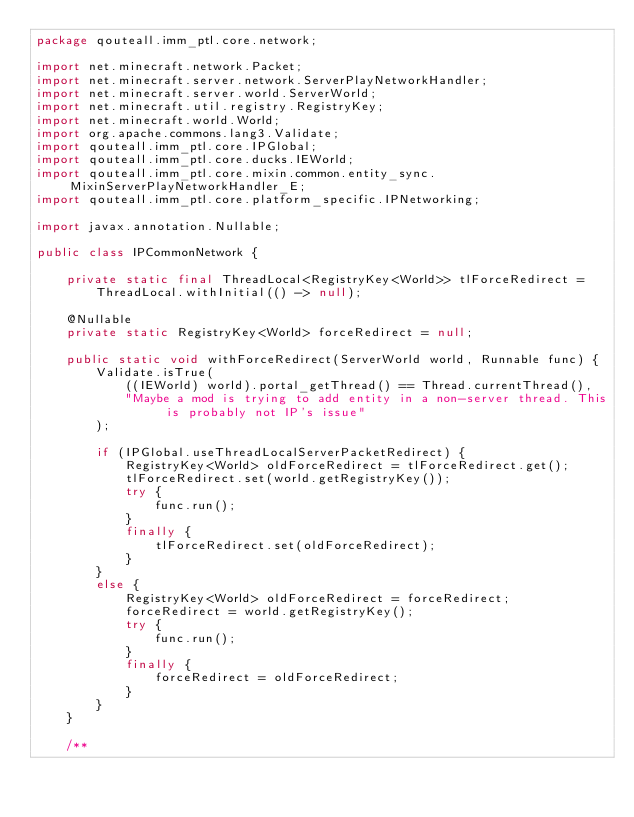<code> <loc_0><loc_0><loc_500><loc_500><_Java_>package qouteall.imm_ptl.core.network;

import net.minecraft.network.Packet;
import net.minecraft.server.network.ServerPlayNetworkHandler;
import net.minecraft.server.world.ServerWorld;
import net.minecraft.util.registry.RegistryKey;
import net.minecraft.world.World;
import org.apache.commons.lang3.Validate;
import qouteall.imm_ptl.core.IPGlobal;
import qouteall.imm_ptl.core.ducks.IEWorld;
import qouteall.imm_ptl.core.mixin.common.entity_sync.MixinServerPlayNetworkHandler_E;
import qouteall.imm_ptl.core.platform_specific.IPNetworking;

import javax.annotation.Nullable;

public class IPCommonNetwork {
    
    private static final ThreadLocal<RegistryKey<World>> tlForceRedirect =
        ThreadLocal.withInitial(() -> null);
    
    @Nullable
    private static RegistryKey<World> forceRedirect = null;
    
    public static void withForceRedirect(ServerWorld world, Runnable func) {
        Validate.isTrue(
            ((IEWorld) world).portal_getThread() == Thread.currentThread(),
            "Maybe a mod is trying to add entity in a non-server thread. This is probably not IP's issue"
        );
        
        if (IPGlobal.useThreadLocalServerPacketRedirect) {
            RegistryKey<World> oldForceRedirect = tlForceRedirect.get();
            tlForceRedirect.set(world.getRegistryKey());
            try {
                func.run();
            }
            finally {
                tlForceRedirect.set(oldForceRedirect);
            }
        }
        else {
            RegistryKey<World> oldForceRedirect = forceRedirect;
            forceRedirect = world.getRegistryKey();
            try {
                func.run();
            }
            finally {
                forceRedirect = oldForceRedirect;
            }
        }
    }
    
    /**</code> 